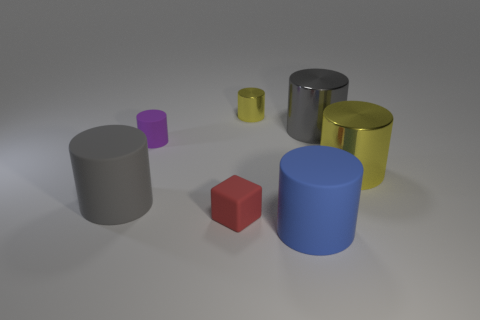Subtract all large yellow metallic cylinders. How many cylinders are left? 5 Subtract all blue balls. How many gray cylinders are left? 2 Subtract all gray cylinders. How many cylinders are left? 4 Add 2 matte cubes. How many objects exist? 9 Subtract 2 cylinders. How many cylinders are left? 4 Subtract all cylinders. How many objects are left? 1 Subtract all cyan cylinders. Subtract all gray balls. How many cylinders are left? 6 Subtract all small yellow blocks. Subtract all gray metal cylinders. How many objects are left? 6 Add 2 gray things. How many gray things are left? 4 Add 3 red objects. How many red objects exist? 4 